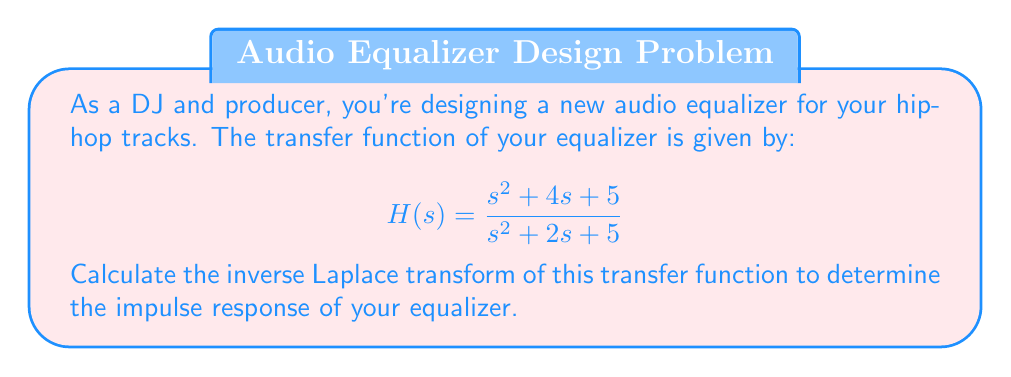Can you solve this math problem? To find the inverse Laplace transform of the given transfer function, we'll follow these steps:

1) First, let's rewrite the transfer function as a sum of partial fractions:

   $$H(s) = \frac{s^2 + 4s + 5}{s^2 + 2s + 5} = 1 + \frac{2s}{s^2 + 2s + 5}$$

2) Now, we need to find the inverse Laplace transform of each term separately:

   a) For the constant term 1, the inverse Laplace transform is simply $\delta(t)$, where $\delta(t)$ is the Dirac delta function.

   b) For the second term, we need to complete the square in the denominator:

      $$\frac{2s}{s^2 + 2s + 5} = \frac{2s}{(s+1)^2 + 4}$$

3) This form can be inverse transformed using the standard result:

   $$\mathcal{L}^{-1}\left\{\frac{s}{(s+a)^2 + b^2}\right\} = e^{-at}\cos(bt)$$

   In our case, $a=1$ and $b=2$.

4) Therefore, the inverse Laplace transform of the second term is:

   $$2e^{-t}\cos(2t)$$

5) Combining the results from steps 2a and 4, we get the final impulse response:

   $$h(t) = \delta(t) + 2e^{-t}\cos(2t)$$

This impulse response represents how your equalizer will respond to an input impulse, which is crucial for understanding its effect on audio signals.
Answer: $$h(t) = \delta(t) + 2e^{-t}\cos(2t)$$ 